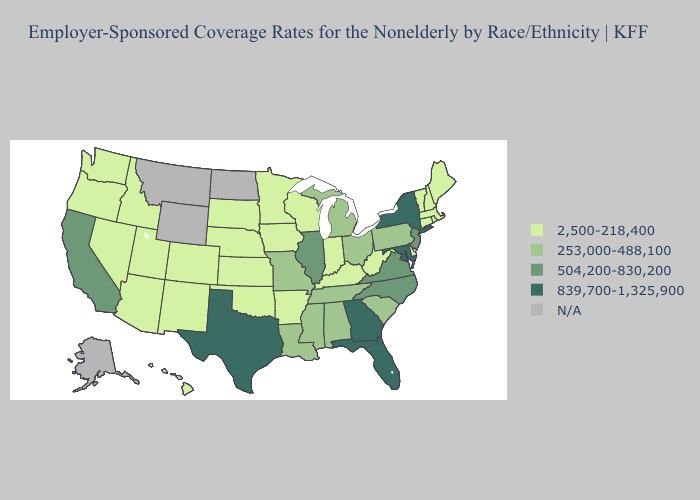Does Florida have the lowest value in the USA?
Keep it brief. No. Does California have the lowest value in the West?
Keep it brief. No. What is the highest value in states that border California?
Be succinct. 2,500-218,400. Does Arizona have the highest value in the West?
Be succinct. No. What is the highest value in states that border Vermont?
Give a very brief answer. 839,700-1,325,900. What is the highest value in the USA?
Give a very brief answer. 839,700-1,325,900. Which states hav the highest value in the MidWest?
Keep it brief. Illinois. Name the states that have a value in the range 839,700-1,325,900?
Be succinct. Florida, Georgia, Maryland, New York, Texas. Among the states that border Texas , does Louisiana have the highest value?
Answer briefly. Yes. How many symbols are there in the legend?
Write a very short answer. 5. Does Minnesota have the highest value in the MidWest?
Keep it brief. No. What is the highest value in states that border Idaho?
Short answer required. 2,500-218,400. Does Pennsylvania have the lowest value in the Northeast?
Short answer required. No. 